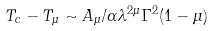Convert formula to latex. <formula><loc_0><loc_0><loc_500><loc_500>T _ { c } - T _ { \mu } \sim A _ { \mu } / \alpha \lambda ^ { 2 \mu } \Gamma ^ { 2 } ( 1 - \mu )</formula> 